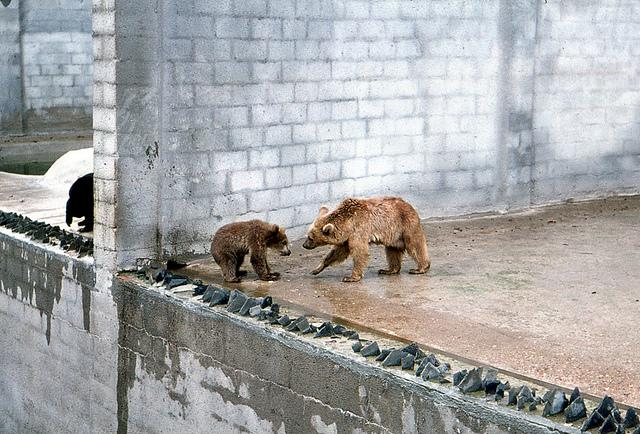What type of bears are in the foreground?

Choices:
A) black
B) polar
C) grizzly
D) panda grizzly 